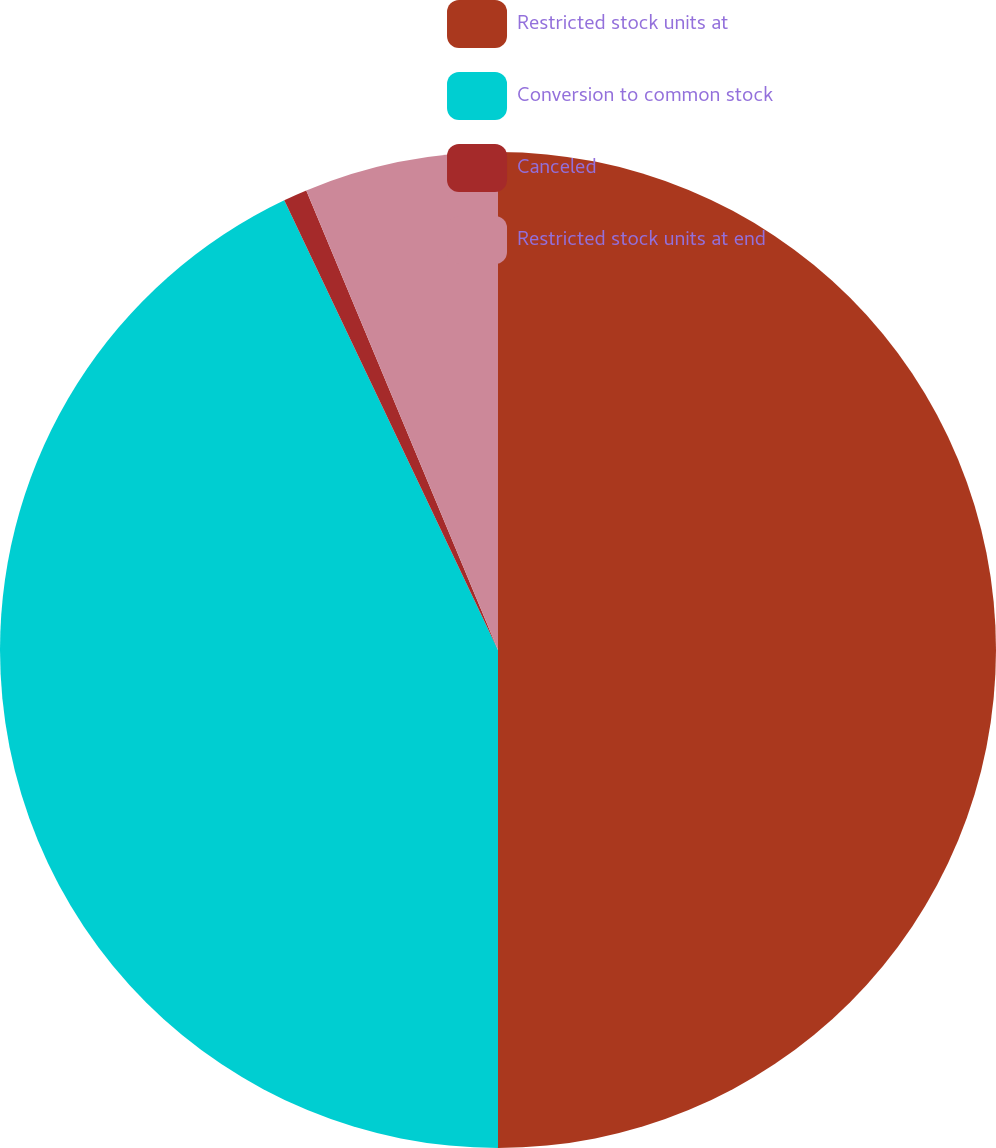Convert chart. <chart><loc_0><loc_0><loc_500><loc_500><pie_chart><fcel>Restricted stock units at<fcel>Conversion to common stock<fcel>Canceled<fcel>Restricted stock units at end<nl><fcel>50.0%<fcel>42.94%<fcel>0.77%<fcel>6.29%<nl></chart> 